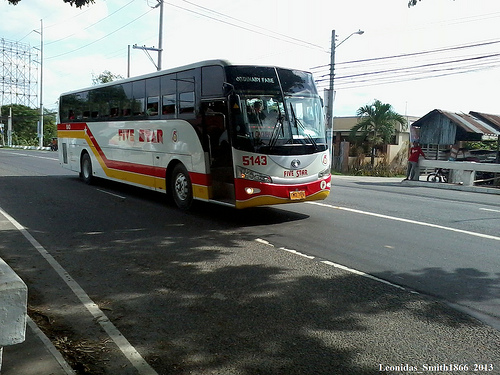What is the destination of the bus? The destination sign on the bus is not clearly visible in the image, so I cannot provide the exact location it is headed to. 